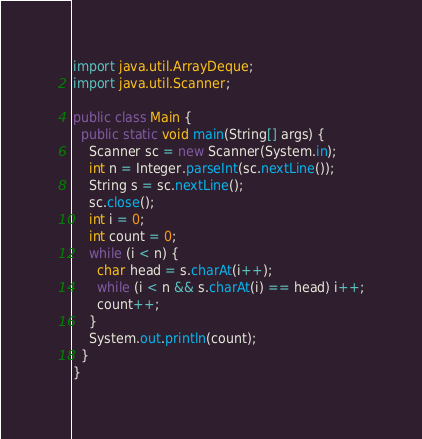Convert code to text. <code><loc_0><loc_0><loc_500><loc_500><_Java_>import java.util.ArrayDeque;
import java.util.Scanner;

public class Main {
  public static void main(String[] args) {
    Scanner sc = new Scanner(System.in);
    int n = Integer.parseInt(sc.nextLine());
    String s = sc.nextLine();
    sc.close();
    int i = 0;
    int count = 0;
    while (i < n) {
      char head = s.charAt(i++);
      while (i < n && s.charAt(i) == head) i++;
      count++;
    }
    System.out.println(count);
  }
}</code> 